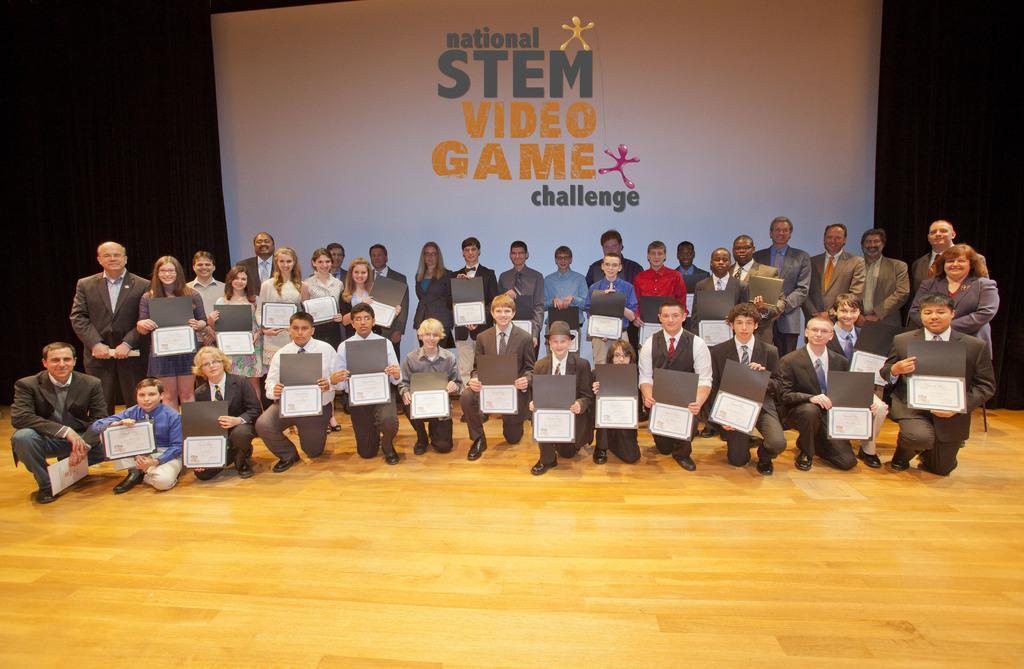In one or two sentences, can you explain what this image depicts? Here I can see a stage. On this few people are standing and few people are sitting on the knees by holding certificates in their hands. Everyone is smiling and giving pose for the picture. In the background, I can see a white color banner on which I can see some text. 